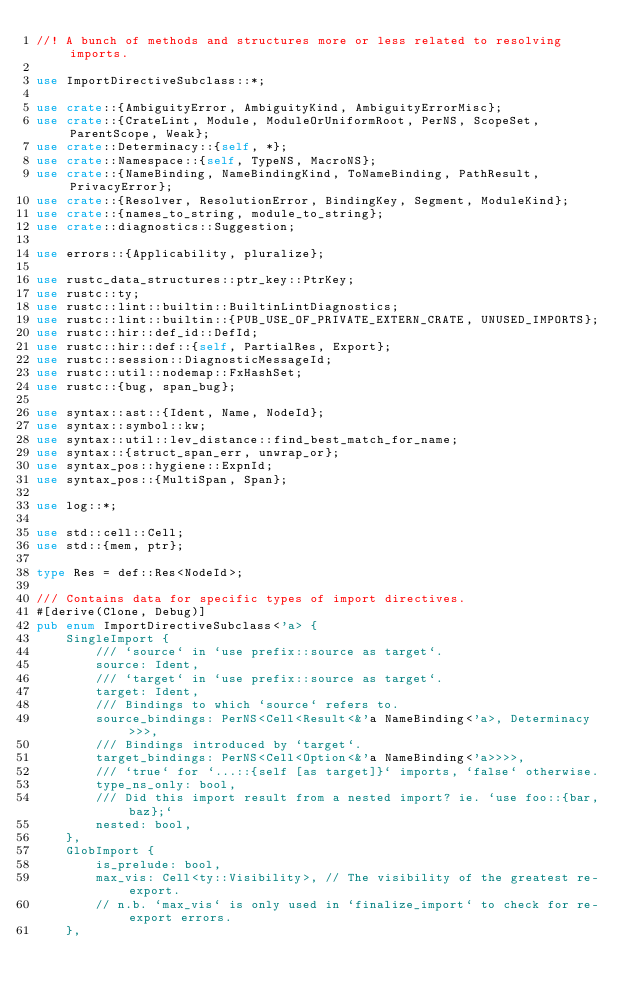Convert code to text. <code><loc_0><loc_0><loc_500><loc_500><_Rust_>//! A bunch of methods and structures more or less related to resolving imports.

use ImportDirectiveSubclass::*;

use crate::{AmbiguityError, AmbiguityKind, AmbiguityErrorMisc};
use crate::{CrateLint, Module, ModuleOrUniformRoot, PerNS, ScopeSet, ParentScope, Weak};
use crate::Determinacy::{self, *};
use crate::Namespace::{self, TypeNS, MacroNS};
use crate::{NameBinding, NameBindingKind, ToNameBinding, PathResult, PrivacyError};
use crate::{Resolver, ResolutionError, BindingKey, Segment, ModuleKind};
use crate::{names_to_string, module_to_string};
use crate::diagnostics::Suggestion;

use errors::{Applicability, pluralize};

use rustc_data_structures::ptr_key::PtrKey;
use rustc::ty;
use rustc::lint::builtin::BuiltinLintDiagnostics;
use rustc::lint::builtin::{PUB_USE_OF_PRIVATE_EXTERN_CRATE, UNUSED_IMPORTS};
use rustc::hir::def_id::DefId;
use rustc::hir::def::{self, PartialRes, Export};
use rustc::session::DiagnosticMessageId;
use rustc::util::nodemap::FxHashSet;
use rustc::{bug, span_bug};

use syntax::ast::{Ident, Name, NodeId};
use syntax::symbol::kw;
use syntax::util::lev_distance::find_best_match_for_name;
use syntax::{struct_span_err, unwrap_or};
use syntax_pos::hygiene::ExpnId;
use syntax_pos::{MultiSpan, Span};

use log::*;

use std::cell::Cell;
use std::{mem, ptr};

type Res = def::Res<NodeId>;

/// Contains data for specific types of import directives.
#[derive(Clone, Debug)]
pub enum ImportDirectiveSubclass<'a> {
    SingleImport {
        /// `source` in `use prefix::source as target`.
        source: Ident,
        /// `target` in `use prefix::source as target`.
        target: Ident,
        /// Bindings to which `source` refers to.
        source_bindings: PerNS<Cell<Result<&'a NameBinding<'a>, Determinacy>>>,
        /// Bindings introduced by `target`.
        target_bindings: PerNS<Cell<Option<&'a NameBinding<'a>>>>,
        /// `true` for `...::{self [as target]}` imports, `false` otherwise.
        type_ns_only: bool,
        /// Did this import result from a nested import? ie. `use foo::{bar, baz};`
        nested: bool,
    },
    GlobImport {
        is_prelude: bool,
        max_vis: Cell<ty::Visibility>, // The visibility of the greatest re-export.
        // n.b. `max_vis` is only used in `finalize_import` to check for re-export errors.
    },</code> 